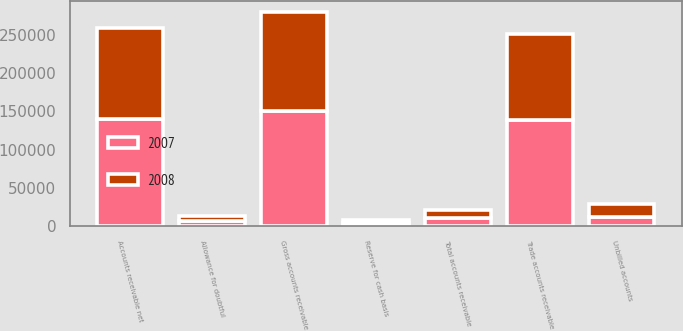<chart> <loc_0><loc_0><loc_500><loc_500><stacked_bar_chart><ecel><fcel>Trade accounts receivable<fcel>Unbilled accounts<fcel>Gross accounts receivable<fcel>Allowance for doubtful<fcel>Reserve for cash basis<fcel>Total accounts receivable<fcel>Accounts receivable net<nl><fcel>2007<fcel>138286<fcel>12596<fcel>150882<fcel>6943<fcel>4327<fcel>11270<fcel>139612<nl><fcel>2008<fcel>113357<fcel>15978<fcel>129335<fcel>6878<fcel>3513<fcel>10391<fcel>118944<nl></chart> 